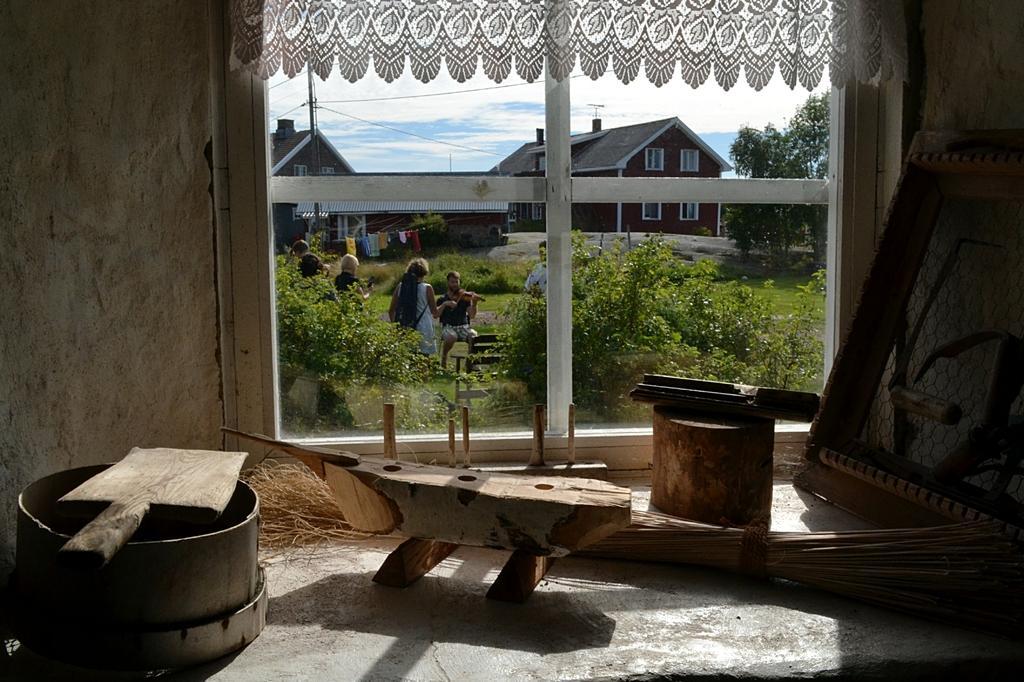How would you summarize this image in a sentence or two? In this picture there are wooden objects at the bottom side of the image and there is a window in the center of the image, there are houses, trees, and people outside the window. 